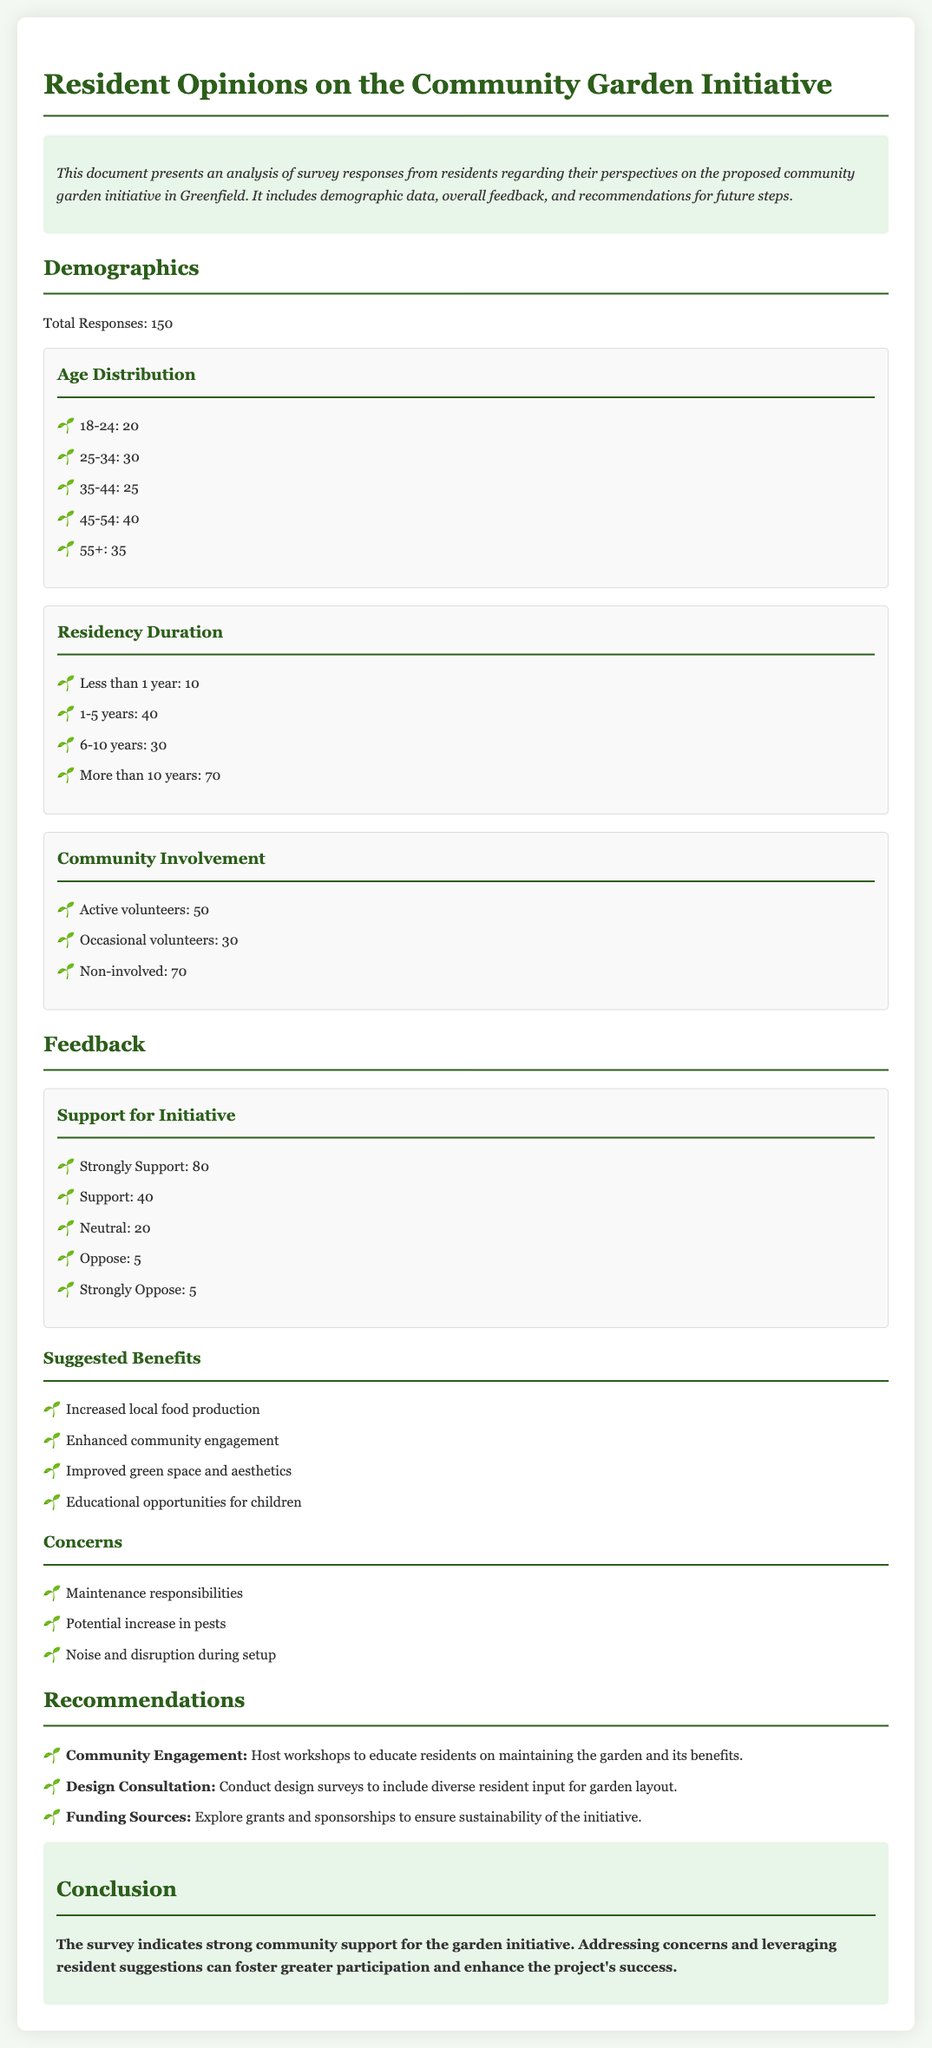What is the total number of survey responses? The document states that there were a total of 150 survey responses from residents.
Answer: 150 How many residents are in the age group 25-34? The age distribution chart lists 30 residents in the 25-34 age group.
Answer: 30 What percentage of residents strongly support the community garden initiative? Strongly Support responses total 80 out of 150, which is approximately 53%.
Answer: 53% What is the main concern raised by residents regarding the community garden? The document lists maintenance responsibilities as one of the primary concerns from residents.
Answer: Maintenance responsibilities What is one suggested benefit of the community garden? The document mentions increased local food production as a suggested benefit.
Answer: Increased local food production How many residents have been in Greenfield for more than 10 years? According to the residency duration chart, there are 70 residents who have lived in Greenfield for more than 10 years.
Answer: 70 What does the document recommend to enhance community engagement? The document recommends hosting workshops to educate residents on maintaining the garden.
Answer: Host workshops What percentage of respondents are non-involved in community activities? There are 70 non-involved residents out of 150 total responses, which is approximately 47%.
Answer: 47% What is the color of the section headers in the document? The section headers are colored #2c5e1a as specified in the style section of the document.
Answer: #2c5e1a 